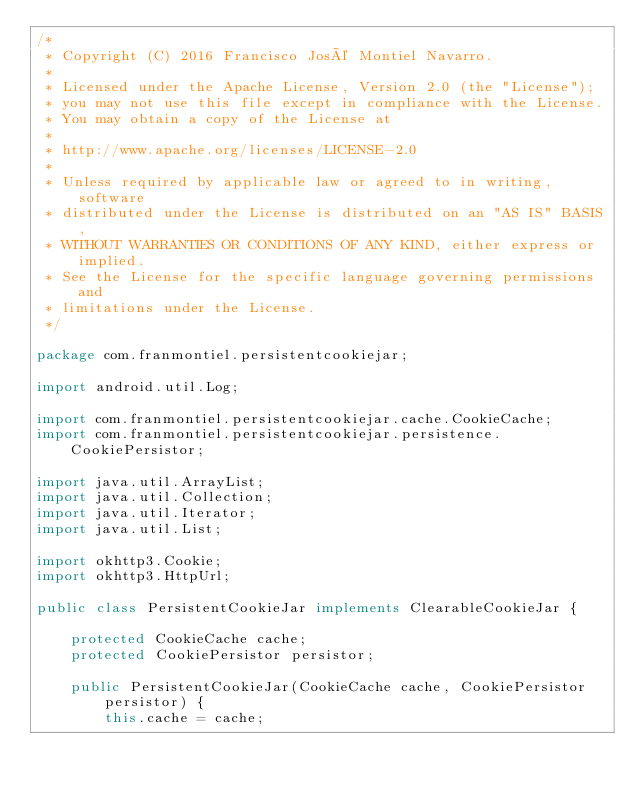<code> <loc_0><loc_0><loc_500><loc_500><_Java_>/*
 * Copyright (C) 2016 Francisco José Montiel Navarro.
 *
 * Licensed under the Apache License, Version 2.0 (the "License");
 * you may not use this file except in compliance with the License.
 * You may obtain a copy of the License at
 *
 * http://www.apache.org/licenses/LICENSE-2.0
 *
 * Unless required by applicable law or agreed to in writing, software
 * distributed under the License is distributed on an "AS IS" BASIS,
 * WITHOUT WARRANTIES OR CONDITIONS OF ANY KIND, either express or implied.
 * See the License for the specific language governing permissions and
 * limitations under the License.
 */

package com.franmontiel.persistentcookiejar;

import android.util.Log;

import com.franmontiel.persistentcookiejar.cache.CookieCache;
import com.franmontiel.persistentcookiejar.persistence.CookiePersistor;

import java.util.ArrayList;
import java.util.Collection;
import java.util.Iterator;
import java.util.List;

import okhttp3.Cookie;
import okhttp3.HttpUrl;

public class PersistentCookieJar implements ClearableCookieJar {

    protected CookieCache cache;
    protected CookiePersistor persistor;

    public PersistentCookieJar(CookieCache cache, CookiePersistor persistor) {
        this.cache = cache;</code> 